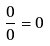Convert formula to latex. <formula><loc_0><loc_0><loc_500><loc_500>\frac { 0 } { 0 } = 0</formula> 